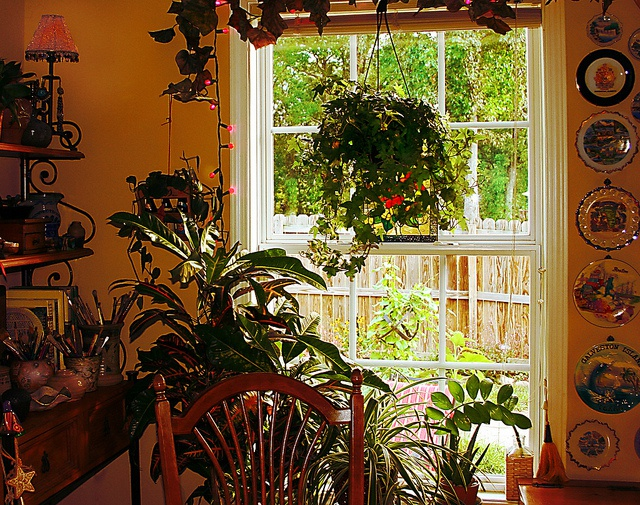Describe the objects in this image and their specific colors. I can see potted plant in maroon, black, brown, and olive tones, potted plant in maroon, black, olive, and ivory tones, chair in maroon, black, and olive tones, potted plant in maroon, black, white, and olive tones, and potted plant in maroon, black, darkgreen, and white tones in this image. 